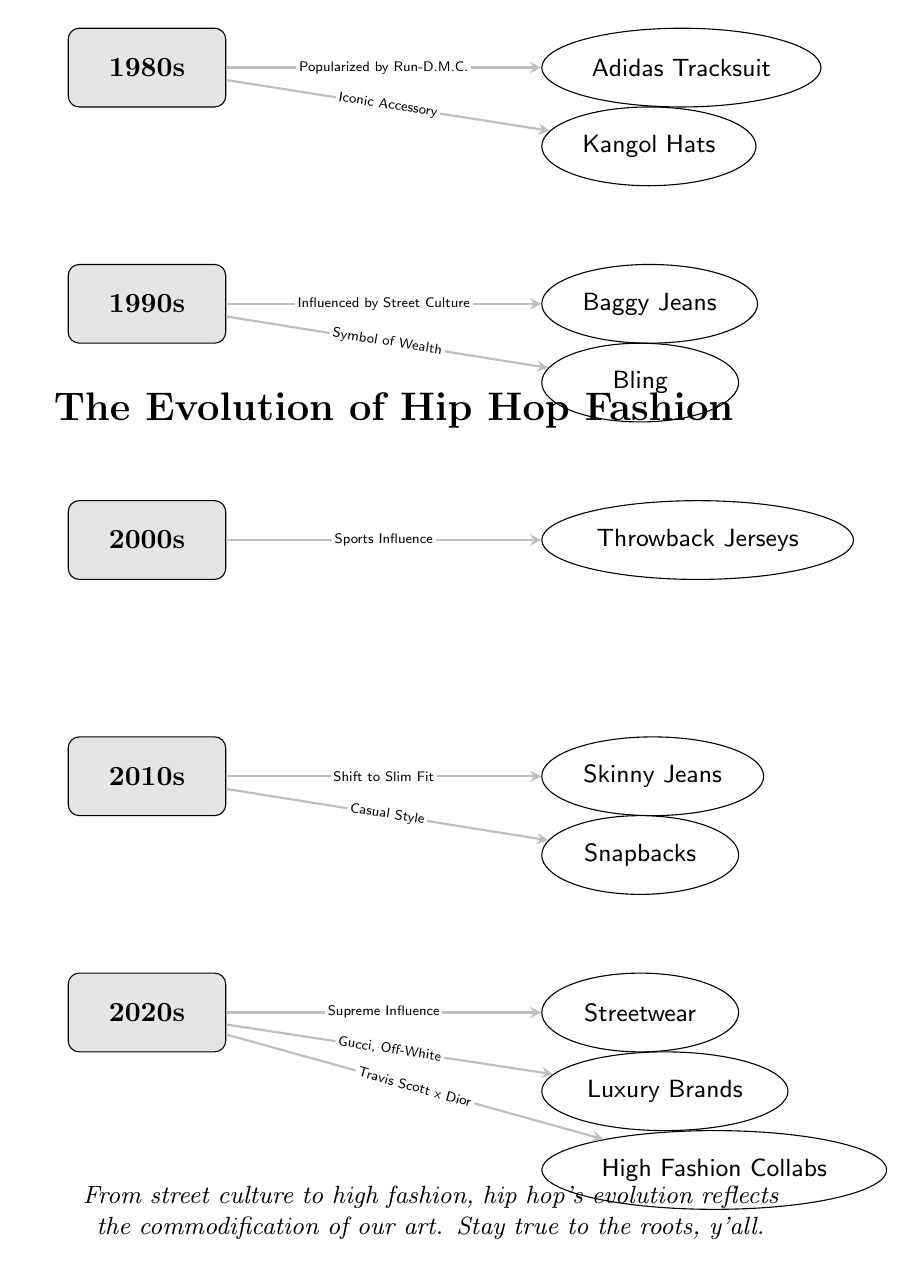What fashion trend was popularized by Run-D.M.C.? The diagram shows that the Adidas Tracksuit was directly connected to the 1980s decade and labeled as popularized by Run-D.M.C.
Answer: Adidas Tracksuit What are two trends from the 1990s? The 1990s section lists Baggy Jeans and Bling as trends, which can be found by looking at the nodes connected to the 1990s decade.
Answer: Baggy Jeans, Bling What significant change in fit is represented in the 2010s? The diagram indicates a Shift to Slim Fit associated with Skinny Jeans, showing a progression from baggy to skinny styles in the timeline.
Answer: Slim Fit How many trends are listed for the 2020s? By counting the nodes connected to the 2020s decade, there are three trends listed: Streetwear, Luxury Brands, and High Fashion Collabs.
Answer: 3 What influenced the trend of Throwback Jerseys? The edge connecting the 2000s decade to the Throwback Jerseys trend states that it is influenced by Sports Influence, indicating what shaped this trend's popularity.
Answer: Sports Influence Which decade introduced Snapbacks? The diagram shows that Snapbacks are connected to the 2010s decade, indicating that this was when this trend emerged in hip hop fashion.
Answer: 2010s What does the label under the 2020s trends suggest about hip hop's evolution? The commentary in the diagram suggests that from street culture to high fashion, hip hop's evolution reflects the commodification of the art form, highlighting a significant shift in its representation.
Answer: Commodification What type of relationship does the diagram display between the 1980s and the Adidas Tracksuit? The edge between the 1980s and the Adidas Tracksuit is labeled, showing a direct influence where Run-D.M.C. popularized this trend.
Answer: Popularized by Run-D.M.C What label connects Baggy Jeans to the 1990s? The relationship labeled "Influenced by Street Culture" connects Baggy Jeans to the 1990s, highlighting the cultural background of the fashion trend in that decade.
Answer: Influenced by Street Culture 